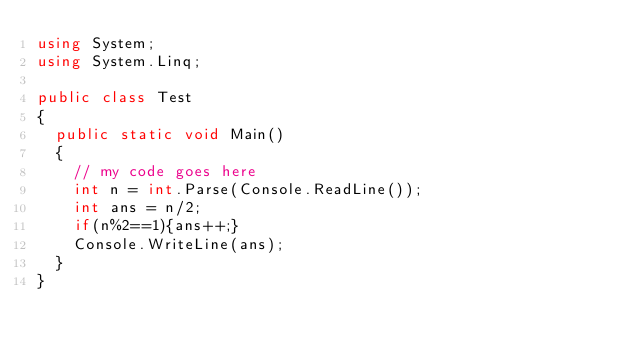<code> <loc_0><loc_0><loc_500><loc_500><_C#_>using System;
using System.Linq;

public class Test
{
	public static void Main()
	{
		// my code goes here
		int n = int.Parse(Console.ReadLine());
		int ans = n/2;
		if(n%2==1){ans++;}
		Console.WriteLine(ans);
	}
}</code> 